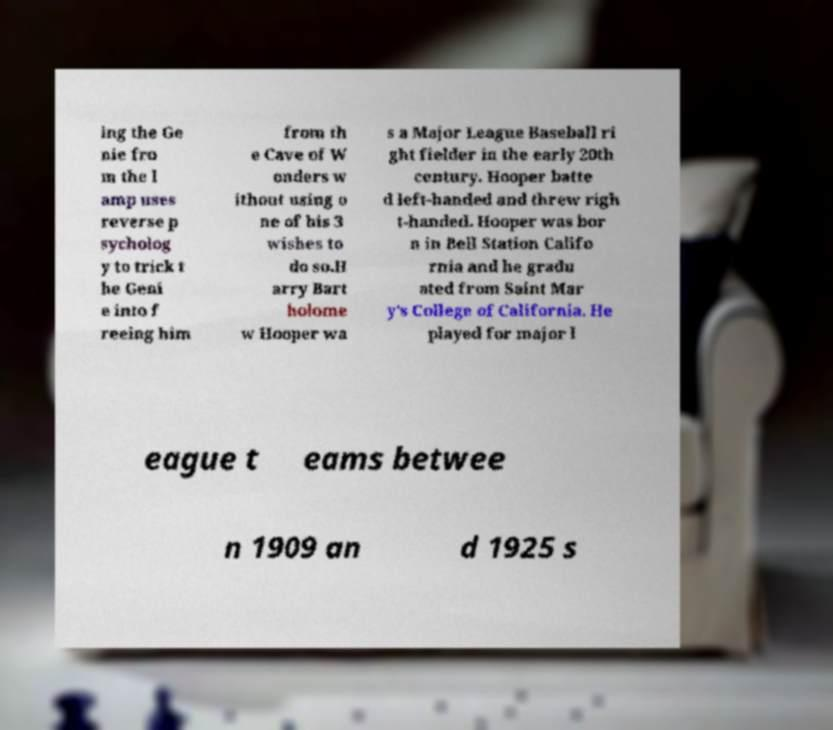For documentation purposes, I need the text within this image transcribed. Could you provide that? ing the Ge nie fro m the l amp uses reverse p sycholog y to trick t he Geni e into f reeing him from th e Cave of W onders w ithout using o ne of his 3 wishes to do so.H arry Bart holome w Hooper wa s a Major League Baseball ri ght fielder in the early 20th century. Hooper batte d left-handed and threw righ t-handed. Hooper was bor n in Bell Station Califo rnia and he gradu ated from Saint Mar y's College of California. He played for major l eague t eams betwee n 1909 an d 1925 s 